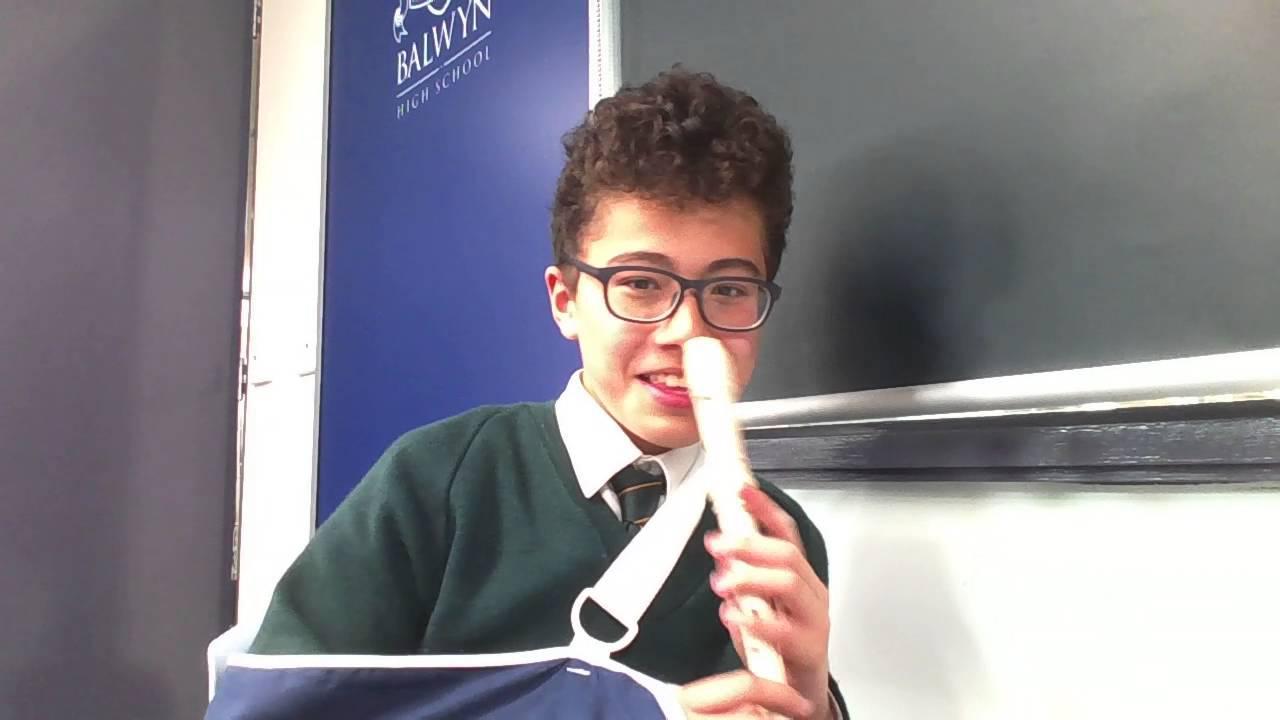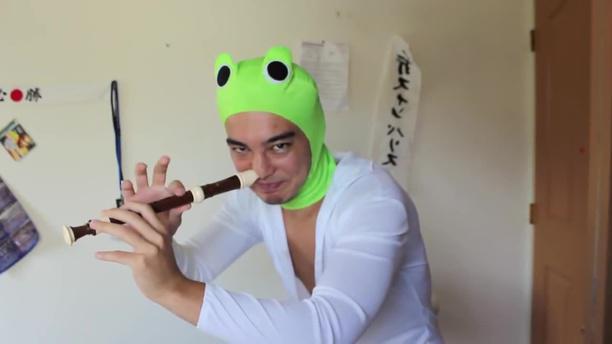The first image is the image on the left, the second image is the image on the right. Considering the images on both sides, is "Each image shows a male holding a flute to one nostril, and the right image features a man in a green frog-eye head covering and white shirt." valid? Answer yes or no. Yes. The first image is the image on the left, the second image is the image on the right. For the images displayed, is the sentence "The left and right image contains the same number of men playing the flute and at least one man is wearing a green hat." factually correct? Answer yes or no. Yes. 